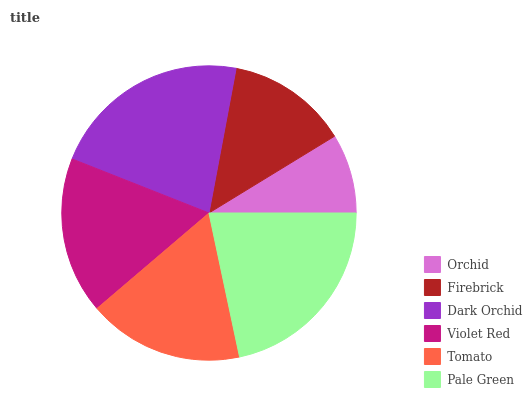Is Orchid the minimum?
Answer yes or no. Yes. Is Dark Orchid the maximum?
Answer yes or no. Yes. Is Firebrick the minimum?
Answer yes or no. No. Is Firebrick the maximum?
Answer yes or no. No. Is Firebrick greater than Orchid?
Answer yes or no. Yes. Is Orchid less than Firebrick?
Answer yes or no. Yes. Is Orchid greater than Firebrick?
Answer yes or no. No. Is Firebrick less than Orchid?
Answer yes or no. No. Is Violet Red the high median?
Answer yes or no. Yes. Is Tomato the low median?
Answer yes or no. Yes. Is Pale Green the high median?
Answer yes or no. No. Is Violet Red the low median?
Answer yes or no. No. 